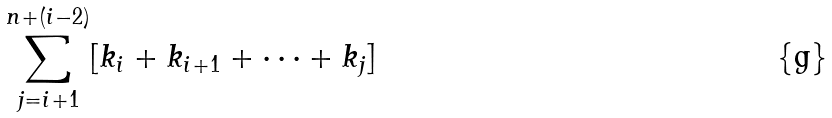Convert formula to latex. <formula><loc_0><loc_0><loc_500><loc_500>\sum _ { j = i + 1 } ^ { n + ( i - 2 ) } [ k _ { i } + k _ { i + 1 } + \dots + k _ { j } ]</formula> 